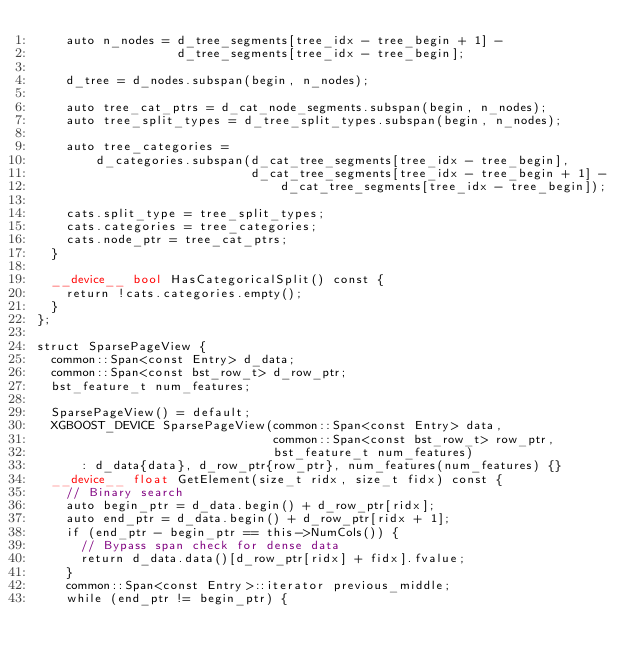<code> <loc_0><loc_0><loc_500><loc_500><_Cuda_>    auto n_nodes = d_tree_segments[tree_idx - tree_begin + 1] -
                   d_tree_segments[tree_idx - tree_begin];

    d_tree = d_nodes.subspan(begin, n_nodes);

    auto tree_cat_ptrs = d_cat_node_segments.subspan(begin, n_nodes);
    auto tree_split_types = d_tree_split_types.subspan(begin, n_nodes);

    auto tree_categories =
        d_categories.subspan(d_cat_tree_segments[tree_idx - tree_begin],
                             d_cat_tree_segments[tree_idx - tree_begin + 1] -
                                 d_cat_tree_segments[tree_idx - tree_begin]);

    cats.split_type = tree_split_types;
    cats.categories = tree_categories;
    cats.node_ptr = tree_cat_ptrs;
  }

  __device__ bool HasCategoricalSplit() const {
    return !cats.categories.empty();
  }
};

struct SparsePageView {
  common::Span<const Entry> d_data;
  common::Span<const bst_row_t> d_row_ptr;
  bst_feature_t num_features;

  SparsePageView() = default;
  XGBOOST_DEVICE SparsePageView(common::Span<const Entry> data,
                                common::Span<const bst_row_t> row_ptr,
                                bst_feature_t num_features)
      : d_data{data}, d_row_ptr{row_ptr}, num_features(num_features) {}
  __device__ float GetElement(size_t ridx, size_t fidx) const {
    // Binary search
    auto begin_ptr = d_data.begin() + d_row_ptr[ridx];
    auto end_ptr = d_data.begin() + d_row_ptr[ridx + 1];
    if (end_ptr - begin_ptr == this->NumCols()) {
      // Bypass span check for dense data
      return d_data.data()[d_row_ptr[ridx] + fidx].fvalue;
    }
    common::Span<const Entry>::iterator previous_middle;
    while (end_ptr != begin_ptr) {</code> 